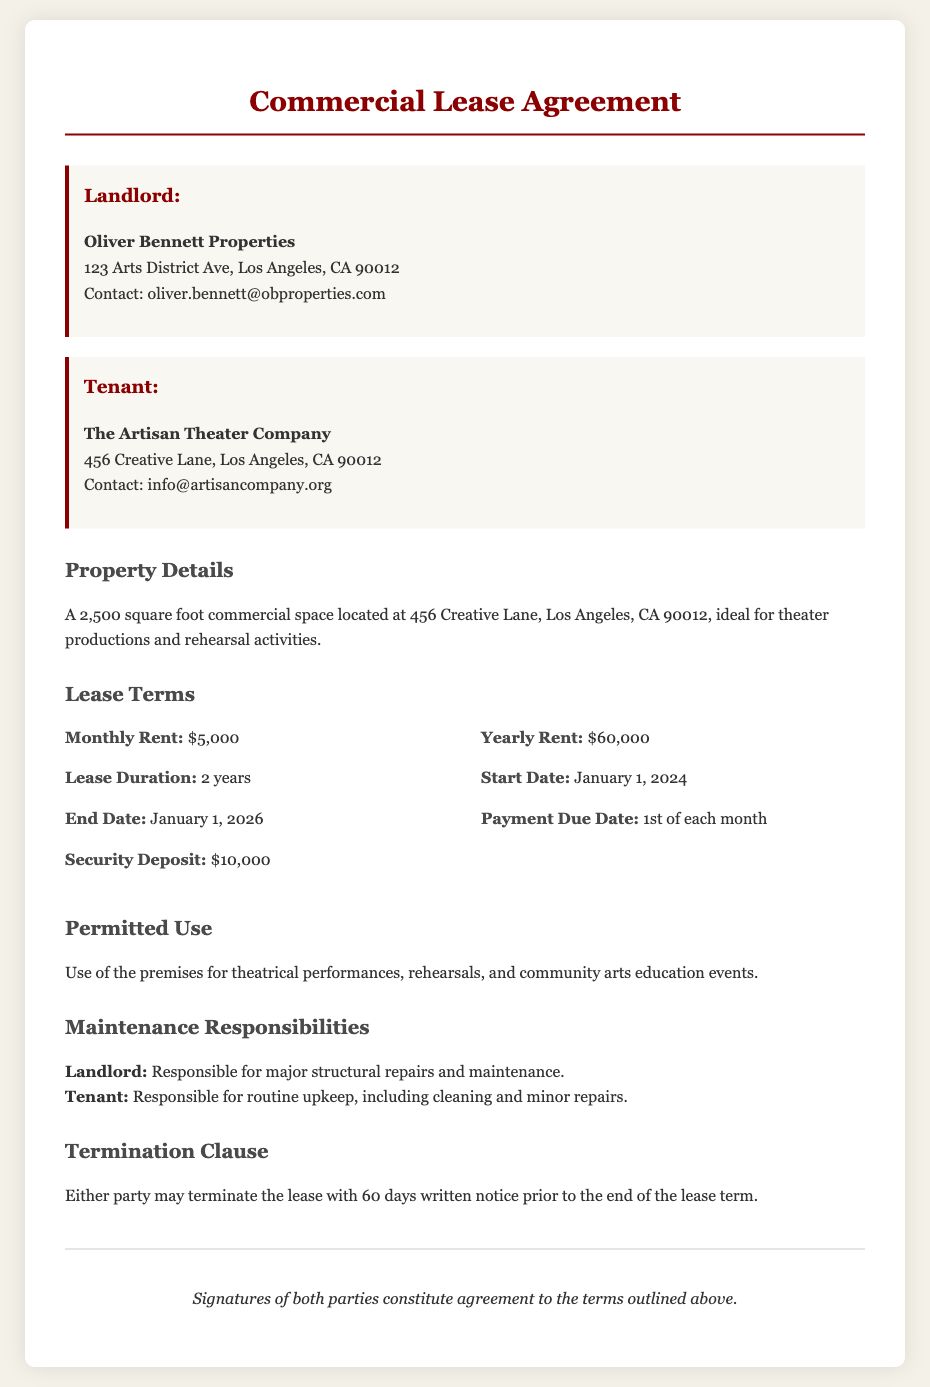What is the monthly rent? The monthly rent is specified in the lease terms section of the document as $5,000.
Answer: $5,000 What is the lease duration? The lease duration is mentioned in the lease terms section as lasting 2 years.
Answer: 2 years Who is the Landlord? The landlord's name is provided in the document, specifically in the party section.
Answer: Oliver Bennett Properties What is the security deposit amount? The security deposit is detailed in the lease terms section as $10,000.
Answer: $10,000 What is the start date of the lease? The start date is clearly indicated in the lease terms section as January 1, 2024.
Answer: January 1, 2024 What are the permitted uses of the property? The permitted uses are listed under the permitted use section, summarizing specific activities allowed on the premises.
Answer: Theatrical performances, rehearsals, and community arts education events What is the payment due date? The payment due date can be found in the lease terms section, detailing when payments are expected.
Answer: 1st of each month What is the termination notice period? The termination clause mentions the notice period required to terminate the lease agreement.
Answer: 60 days Who is responsible for major structural repairs? The maintenance responsibilities section outlines who is accountable for major repairs, specifically assigning duties.
Answer: Landlord What is the end date of the lease? The end date is specified in the lease terms section, indicating when the lease will conclude.
Answer: January 1, 2026 